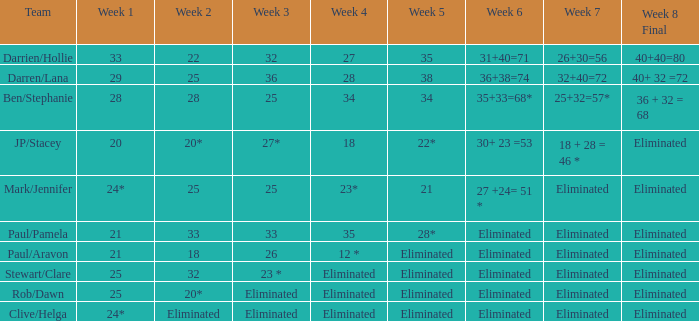Name the team for week 1 of 28 Ben/Stephanie. 